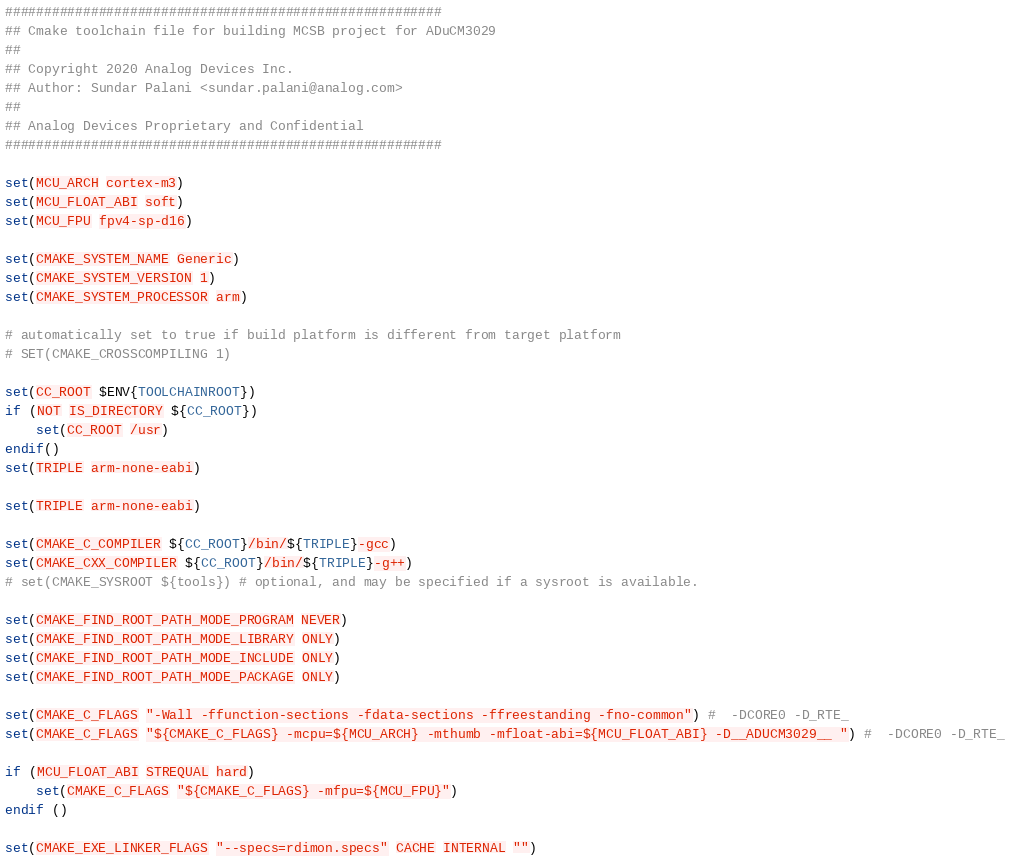<code> <loc_0><loc_0><loc_500><loc_500><_CMake_>########################################################
## Cmake toolchain file for building MCSB project for ADuCM3029
##
## Copyright 2020 Analog Devices Inc.
## Author: Sundar Palani <sundar.palani@analog.com>
##
## Analog Devices Proprietary and Confidential
########################################################

set(MCU_ARCH cortex-m3)
set(MCU_FLOAT_ABI soft)
set(MCU_FPU fpv4-sp-d16)

set(CMAKE_SYSTEM_NAME Generic)
set(CMAKE_SYSTEM_VERSION 1)
set(CMAKE_SYSTEM_PROCESSOR arm)

# automatically set to true if build platform is different from target platform
# SET(CMAKE_CROSSCOMPILING 1)

set(CC_ROOT $ENV{TOOLCHAINROOT})
if (NOT IS_DIRECTORY ${CC_ROOT})
    set(CC_ROOT /usr)
endif()
set(TRIPLE arm-none-eabi)

set(TRIPLE arm-none-eabi)

set(CMAKE_C_COMPILER ${CC_ROOT}/bin/${TRIPLE}-gcc)
set(CMAKE_CXX_COMPILER ${CC_ROOT}/bin/${TRIPLE}-g++)
# set(CMAKE_SYSROOT ${tools}) # optional, and may be specified if a sysroot is available.

set(CMAKE_FIND_ROOT_PATH_MODE_PROGRAM NEVER)
set(CMAKE_FIND_ROOT_PATH_MODE_LIBRARY ONLY)
set(CMAKE_FIND_ROOT_PATH_MODE_INCLUDE ONLY)
set(CMAKE_FIND_ROOT_PATH_MODE_PACKAGE ONLY)

set(CMAKE_C_FLAGS "-Wall -ffunction-sections -fdata-sections -ffreestanding -fno-common") #  -DCORE0 -D_RTE_
set(CMAKE_C_FLAGS "${CMAKE_C_FLAGS} -mcpu=${MCU_ARCH} -mthumb -mfloat-abi=${MCU_FLOAT_ABI} -D__ADUCM3029__ ") #  -DCORE0 -D_RTE_

if (MCU_FLOAT_ABI STREQUAL hard)
    set(CMAKE_C_FLAGS "${CMAKE_C_FLAGS} -mfpu=${MCU_FPU}")
endif ()

set(CMAKE_EXE_LINKER_FLAGS "--specs=rdimon.specs" CACHE INTERNAL "")
</code> 